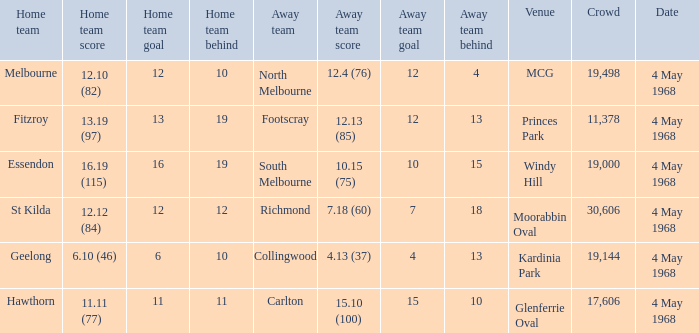Help me parse the entirety of this table. {'header': ['Home team', 'Home team score', 'Home team goal', 'Home team behind', 'Away team', 'Away team score', 'Away team goal', 'Away team behind', 'Venue', 'Crowd', 'Date'], 'rows': [['Melbourne', '12.10 (82)', '12', '10', 'North Melbourne', '12.4 (76)', '12', '4', 'MCG', '19,498', '4 May 1968'], ['Fitzroy', '13.19 (97)', '13', '19', 'Footscray', '12.13 (85)', '12', '13', 'Princes Park', '11,378', '4 May 1968'], ['Essendon', '16.19 (115)', '16', '19', 'South Melbourne', '10.15 (75)', '10', '15', 'Windy Hill', '19,000', '4 May 1968'], ['St Kilda', '12.12 (84)', '12', '12', 'Richmond', '7.18 (60)', '7', '18', 'Moorabbin Oval', '30,606', '4 May 1968'], ['Geelong', '6.10 (46)', '6', '10', 'Collingwood', '4.13 (37)', '4', '13', 'Kardinia Park', '19,144', '4 May 1968'], ['Hawthorn', '11.11 (77)', '11', '11', 'Carlton', '15.10 (100)', '15', '10', 'Glenferrie Oval', '17,606', '4 May 1968']]} What away team played at Kardinia Park? 4.13 (37). 